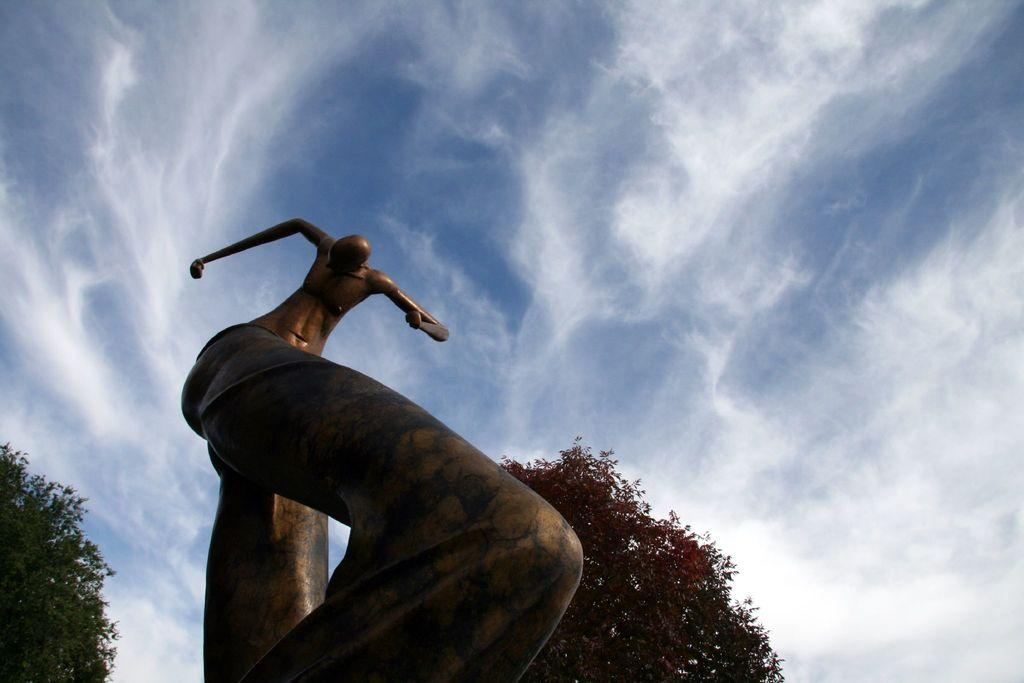What is the main subject in the image? There is a statue in the image. What can be seen in the background of the image? There are trees in the background of the image. How would you describe the sky in the image? The sky is blue and cloudy in the image. What type of soup is being served on the string in the image? There is no soup or string present in the image. 